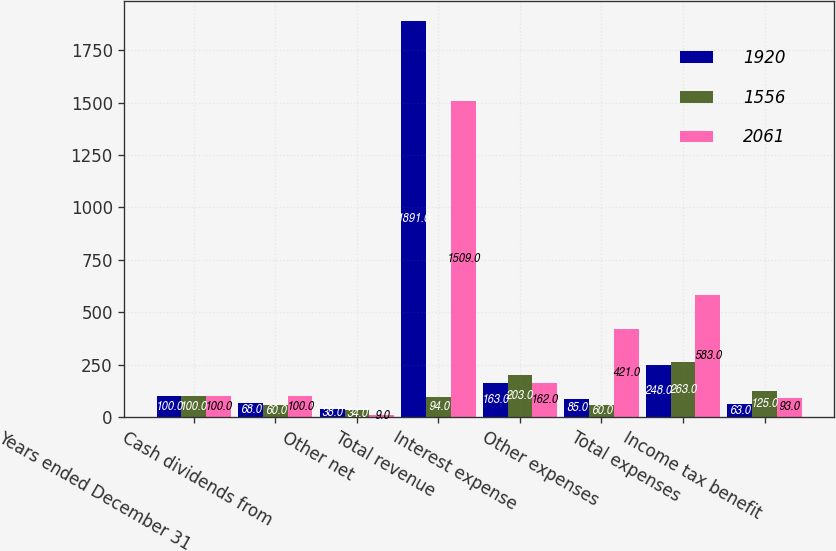Convert chart. <chart><loc_0><loc_0><loc_500><loc_500><stacked_bar_chart><ecel><fcel>Years ended December 31<fcel>Cash dividends from<fcel>Other net<fcel>Total revenue<fcel>Interest expense<fcel>Other expenses<fcel>Total expenses<fcel>Income tax benefit<nl><fcel>1920<fcel>100<fcel>68<fcel>38<fcel>1891<fcel>163<fcel>85<fcel>248<fcel>63<nl><fcel>1556<fcel>100<fcel>60<fcel>34<fcel>94<fcel>203<fcel>60<fcel>263<fcel>125<nl><fcel>2061<fcel>100<fcel>100<fcel>9<fcel>1509<fcel>162<fcel>421<fcel>583<fcel>93<nl></chart> 